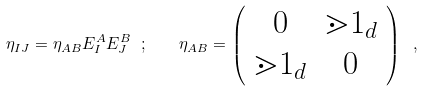Convert formula to latex. <formula><loc_0><loc_0><loc_500><loc_500>\eta _ { I J } = \eta _ { A B } E ^ { A } _ { I } E ^ { B } _ { J } \ ; \quad \eta _ { A B } = \left ( \begin{array} { c c } 0 & \mathbb { m } { 1 } _ { d } \\ \mathbb { m } { 1 } _ { d } & 0 \end{array} \right ) \ ,</formula> 